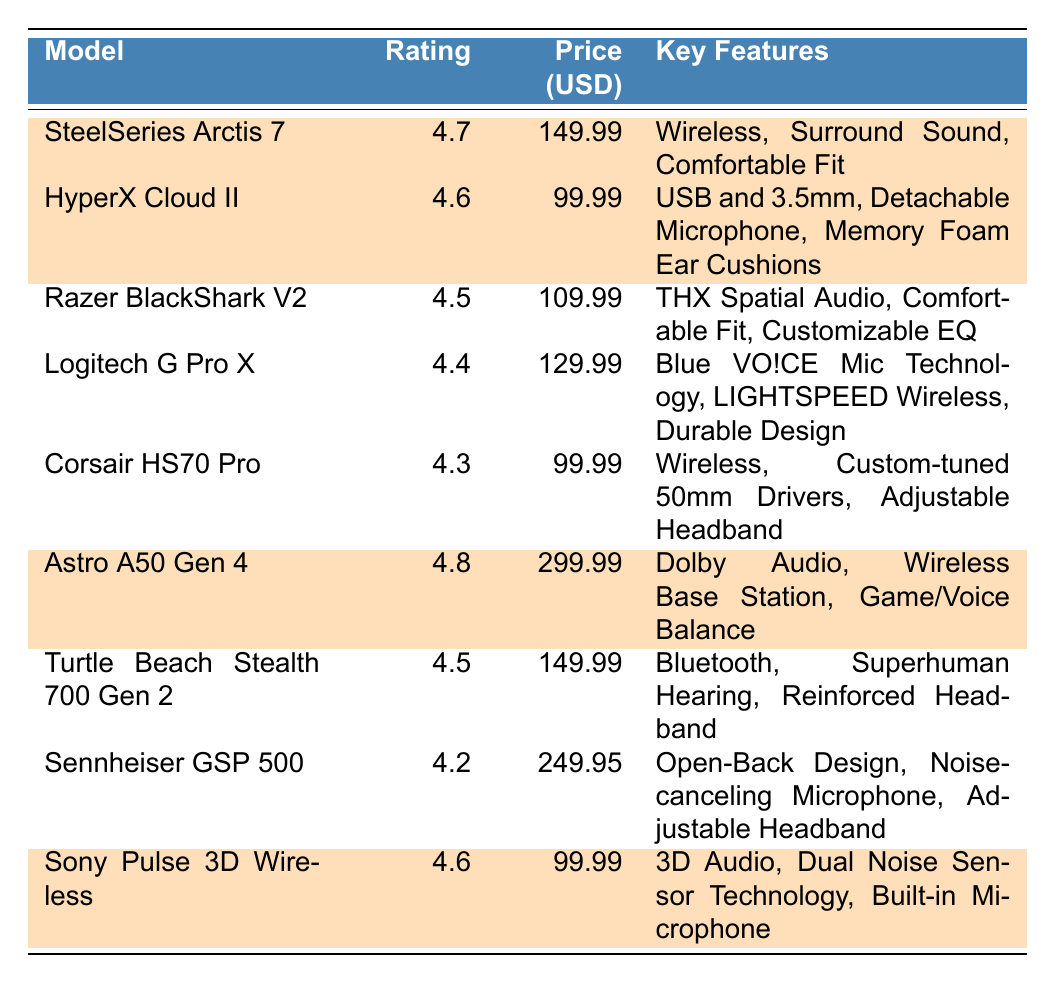What is the user satisfaction rating of the SteelSeries Arctis 7? The SteelSeries Arctis 7 is listed in the table with a user satisfaction rating of 4.7.
Answer: 4.7 What are the key features of the Astro A50 Gen 4? The Astro A50 Gen 4 has the following key features listed: Dolby Audio, Wireless Base Station, Game/Voice Balance.
Answer: Dolby Audio, Wireless Base Station, Game/Voice Balance Which headset has the highest user satisfaction rating and what is it? The highest user satisfaction rating in the table is for the Astro A50 Gen 4, which has a rating of 4.8.
Answer: Astro A50 Gen 4, 4.8 How much does the HyperX Cloud II cost? The price listed for the HyperX Cloud II in the table is 99.99 USD.
Answer: 99.99 USD Is the Razer BlackShark V2 rated higher than the Logitech G Pro X? The Razer BlackShark V2 has a rating of 4.5 while the Logitech G Pro X has a rating of 4.4. Since 4.5 is higher than 4.4, the Razer BlackShark V2 is indeed rated higher.
Answer: Yes What is the average user satisfaction rating of the highlighted headsets? The highlighted headsets are the SteelSeries Arctis 7 (4.7), HyperX Cloud II (4.6), Astro A50 Gen 4 (4.8), and Sony Pulse 3D Wireless (4.6). Summing these ratings gives 4.7 + 4.6 + 4.8 + 4.6 = 19. Let’s divide by 4 (the number of highlighted headsets): 19 / 4 = 4.75.
Answer: 4.75 Which headset is the cheapest? Among the listed headsets, the cheapest one is the HyperX Cloud II, priced at 99.99 USD.
Answer: HyperX Cloud II Are there any headsets with a user satisfaction rating of 4.4 or above that cost less than 150 USD? The headsets with ratings of 4.4 or above are SteelSeries Arctis 7 (4.7, 149.99 USD), HyperX Cloud II (4.6, 99.99 USD), Razer BlackShark V2 (4.5, 109.99 USD), Logitech G Pro X (4.4, 129.99 USD), and Sony Pulse 3D Wireless (4.6, 99.99 USD). Out of these, HyperX Cloud II and Sony Pulse 3D Wireless cost less than 150 USD.
Answer: Yes What is the price difference between the most expensive headset and the least expensive headset? The most expensive headset is the Astro A50 Gen 4 at 299.99 USD, and the least expensive is the HyperX Cloud II at 99.99 USD. The difference is 299.99 - 99.99 = 200.
Answer: 200 USD Which headset features an adjustable headband and has a rating of 4.2 or above? From the table, the headsets with an adjustable headband that have ratings of 4.2 or above are SteelSeries Arctis 7 (4.7), Logitech G Pro X (4.4), Corsair HS70 Pro (4.3), and Sennheiser GSP 500 (4.2).
Answer: SteelSeries Arctis 7, Logitech G Pro X, Corsair HS70 Pro, Sennheiser GSP 500 